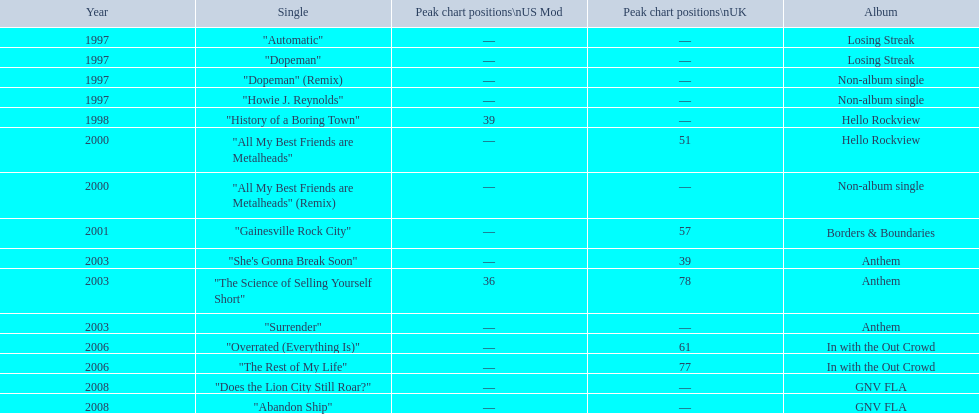What was the usual position of their singles on the uk charts? 60.5. Would you be able to parse every entry in this table? {'header': ['Year', 'Single', 'Peak chart positions\\nUS Mod', 'Peak chart positions\\nUK', 'Album'], 'rows': [['1997', '"Automatic"', '—', '—', 'Losing Streak'], ['1997', '"Dopeman"', '—', '—', 'Losing Streak'], ['1997', '"Dopeman" (Remix)', '—', '—', 'Non-album single'], ['1997', '"Howie J. Reynolds"', '—', '—', 'Non-album single'], ['1998', '"History of a Boring Town"', '39', '—', 'Hello Rockview'], ['2000', '"All My Best Friends are Metalheads"', '—', '51', 'Hello Rockview'], ['2000', '"All My Best Friends are Metalheads" (Remix)', '—', '—', 'Non-album single'], ['2001', '"Gainesville Rock City"', '—', '57', 'Borders & Boundaries'], ['2003', '"She\'s Gonna Break Soon"', '—', '39', 'Anthem'], ['2003', '"The Science of Selling Yourself Short"', '36', '78', 'Anthem'], ['2003', '"Surrender"', '—', '—', 'Anthem'], ['2006', '"Overrated (Everything Is)"', '—', '61', 'In with the Out Crowd'], ['2006', '"The Rest of My Life"', '—', '77', 'In with the Out Crowd'], ['2008', '"Does the Lion City Still Roar?"', '—', '—', 'GNV FLA'], ['2008', '"Abandon Ship"', '—', '—', 'GNV FLA']]} 